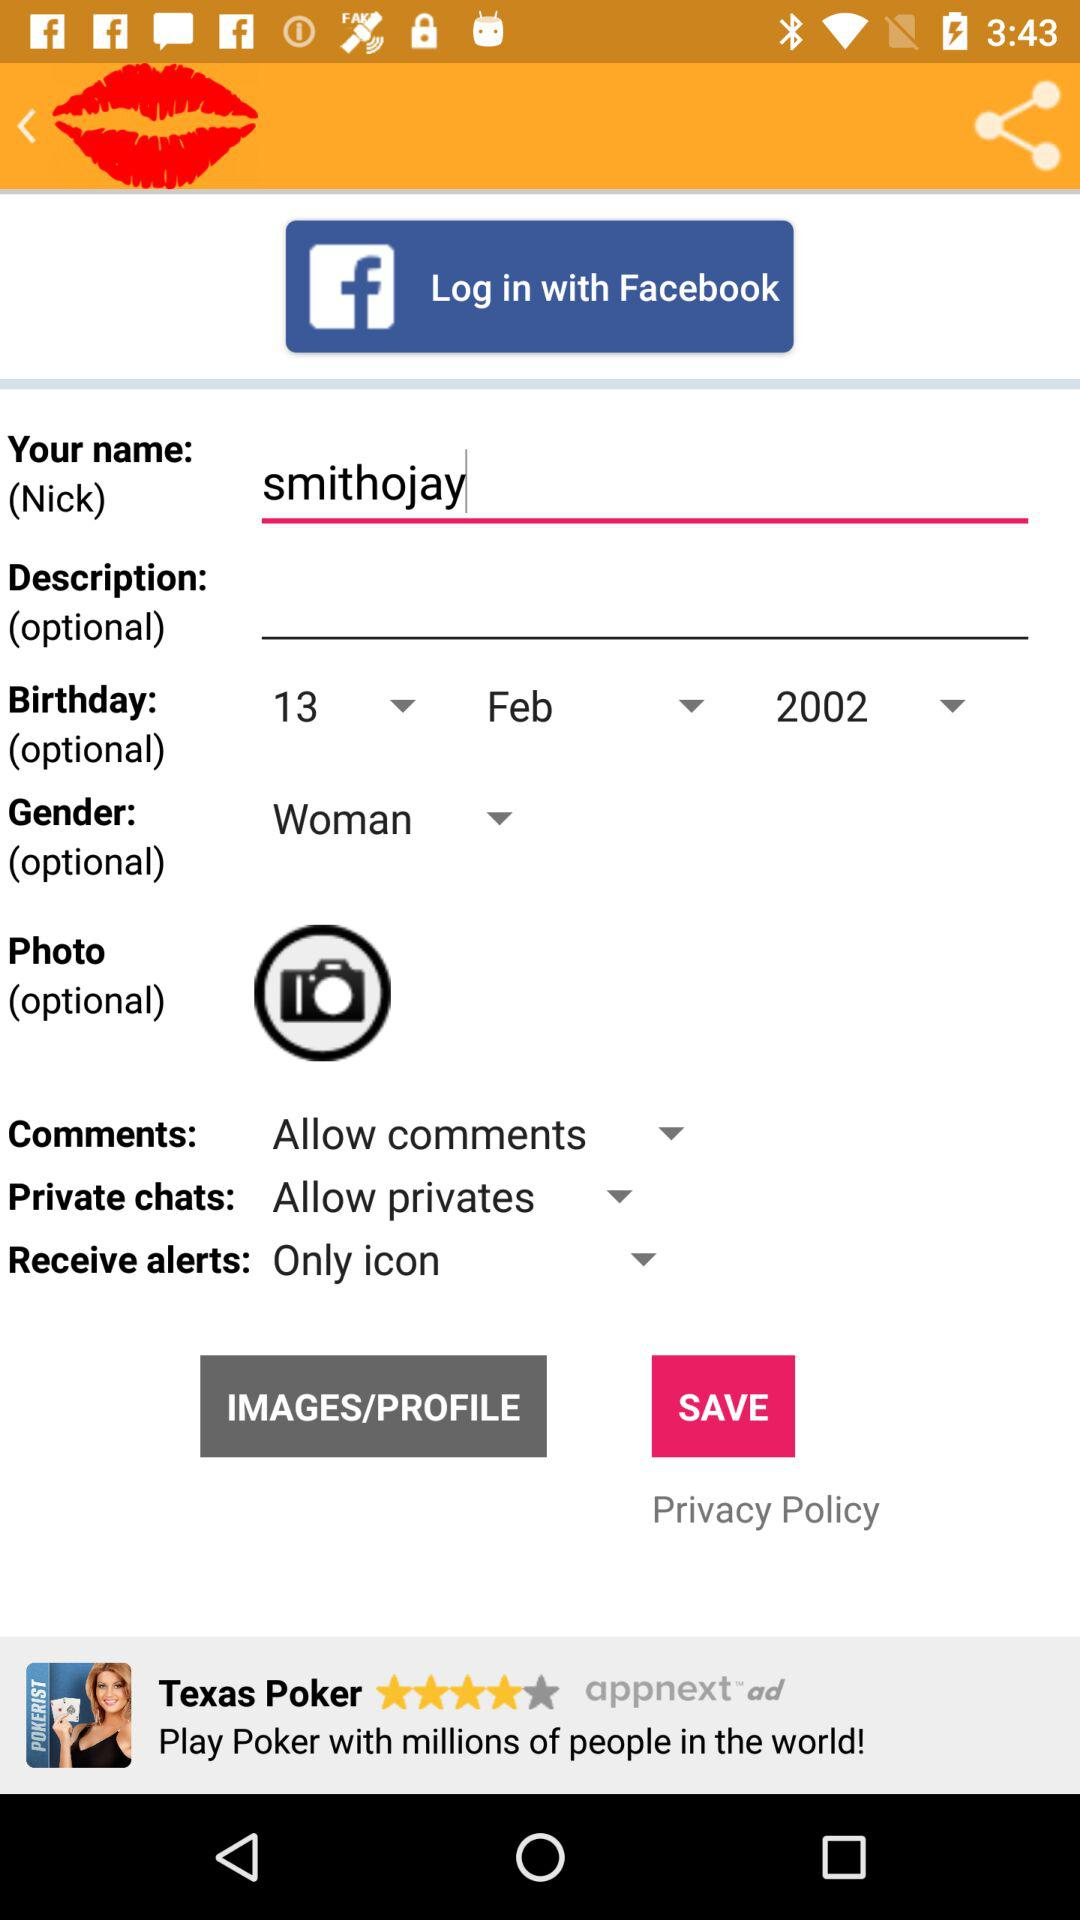What is the date of birth? The date of birth is February 13, 2002. 